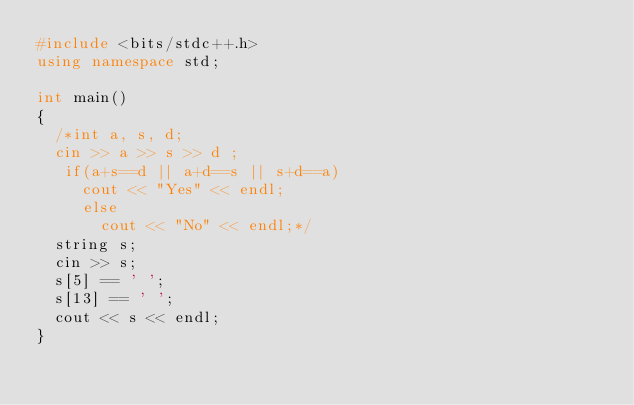Convert code to text. <code><loc_0><loc_0><loc_500><loc_500><_C++_>#include <bits/stdc++.h>
using namespace std;

int main()
{
  /*int a, s, d;
  cin >> a >> s >> d ;
   if(a+s==d || a+d==s || s+d==a)
     cout << "Yes" << endl;
     else
       cout << "No" << endl;*/
  string s;
  cin >> s;
  s[5] == ' ';
  s[13] == ' ';
  cout << s << endl;
}  
</code> 